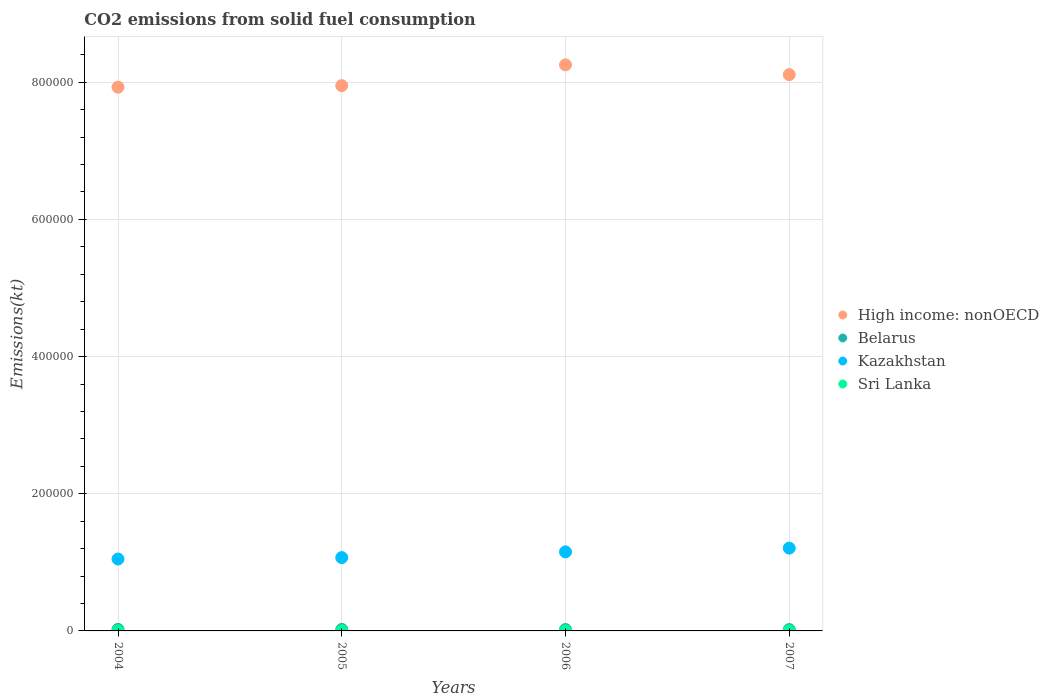Is the number of dotlines equal to the number of legend labels?
Provide a short and direct response. Yes. What is the amount of CO2 emitted in Belarus in 2004?
Provide a succinct answer. 2181.86. Across all years, what is the maximum amount of CO2 emitted in Sri Lanka?
Offer a very short reply. 231.02. Across all years, what is the minimum amount of CO2 emitted in Kazakhstan?
Ensure brevity in your answer.  1.05e+05. What is the total amount of CO2 emitted in Kazakhstan in the graph?
Provide a short and direct response. 4.48e+05. What is the difference between the amount of CO2 emitted in High income: nonOECD in 2004 and that in 2007?
Your answer should be compact. -1.83e+04. What is the difference between the amount of CO2 emitted in Sri Lanka in 2006 and the amount of CO2 emitted in High income: nonOECD in 2007?
Your answer should be compact. -8.11e+05. What is the average amount of CO2 emitted in Kazakhstan per year?
Give a very brief answer. 1.12e+05. In the year 2005, what is the difference between the amount of CO2 emitted in Kazakhstan and amount of CO2 emitted in High income: nonOECD?
Offer a terse response. -6.88e+05. What is the ratio of the amount of CO2 emitted in Kazakhstan in 2005 to that in 2006?
Provide a short and direct response. 0.93. Is the difference between the amount of CO2 emitted in Kazakhstan in 2004 and 2006 greater than the difference between the amount of CO2 emitted in High income: nonOECD in 2004 and 2006?
Keep it short and to the point. Yes. What is the difference between the highest and the second highest amount of CO2 emitted in Kazakhstan?
Keep it short and to the point. 5482.16. What is the difference between the highest and the lowest amount of CO2 emitted in Kazakhstan?
Keep it short and to the point. 1.59e+04. In how many years, is the amount of CO2 emitted in Kazakhstan greater than the average amount of CO2 emitted in Kazakhstan taken over all years?
Give a very brief answer. 2. Is the sum of the amount of CO2 emitted in Kazakhstan in 2006 and 2007 greater than the maximum amount of CO2 emitted in High income: nonOECD across all years?
Provide a short and direct response. No. Is it the case that in every year, the sum of the amount of CO2 emitted in Sri Lanka and amount of CO2 emitted in Belarus  is greater than the sum of amount of CO2 emitted in High income: nonOECD and amount of CO2 emitted in Kazakhstan?
Give a very brief answer. No. Does the amount of CO2 emitted in Kazakhstan monotonically increase over the years?
Provide a short and direct response. Yes. Is the amount of CO2 emitted in Kazakhstan strictly greater than the amount of CO2 emitted in Belarus over the years?
Provide a succinct answer. Yes. How many dotlines are there?
Provide a short and direct response. 4. How many years are there in the graph?
Your response must be concise. 4. What is the difference between two consecutive major ticks on the Y-axis?
Make the answer very short. 2.00e+05. Where does the legend appear in the graph?
Your answer should be compact. Center right. How are the legend labels stacked?
Provide a succinct answer. Vertical. What is the title of the graph?
Provide a short and direct response. CO2 emissions from solid fuel consumption. What is the label or title of the X-axis?
Your answer should be very brief. Years. What is the label or title of the Y-axis?
Ensure brevity in your answer.  Emissions(kt). What is the Emissions(kt) in High income: nonOECD in 2004?
Your answer should be very brief. 7.93e+05. What is the Emissions(kt) in Belarus in 2004?
Give a very brief answer. 2181.86. What is the Emissions(kt) in Kazakhstan in 2004?
Ensure brevity in your answer.  1.05e+05. What is the Emissions(kt) in Sri Lanka in 2004?
Ensure brevity in your answer.  231.02. What is the Emissions(kt) of High income: nonOECD in 2005?
Provide a short and direct response. 7.95e+05. What is the Emissions(kt) in Belarus in 2005?
Provide a short and direct response. 2167.2. What is the Emissions(kt) of Kazakhstan in 2005?
Offer a terse response. 1.07e+05. What is the Emissions(kt) of Sri Lanka in 2005?
Your answer should be very brief. 231.02. What is the Emissions(kt) of High income: nonOECD in 2006?
Your answer should be very brief. 8.25e+05. What is the Emissions(kt) in Belarus in 2006?
Keep it short and to the point. 2057.19. What is the Emissions(kt) in Kazakhstan in 2006?
Offer a terse response. 1.15e+05. What is the Emissions(kt) in Sri Lanka in 2006?
Give a very brief answer. 227.35. What is the Emissions(kt) of High income: nonOECD in 2007?
Provide a short and direct response. 8.11e+05. What is the Emissions(kt) in Belarus in 2007?
Offer a very short reply. 1961.85. What is the Emissions(kt) of Kazakhstan in 2007?
Provide a succinct answer. 1.21e+05. What is the Emissions(kt) in Sri Lanka in 2007?
Your answer should be compact. 161.35. Across all years, what is the maximum Emissions(kt) of High income: nonOECD?
Offer a terse response. 8.25e+05. Across all years, what is the maximum Emissions(kt) in Belarus?
Give a very brief answer. 2181.86. Across all years, what is the maximum Emissions(kt) of Kazakhstan?
Your answer should be very brief. 1.21e+05. Across all years, what is the maximum Emissions(kt) in Sri Lanka?
Ensure brevity in your answer.  231.02. Across all years, what is the minimum Emissions(kt) of High income: nonOECD?
Your response must be concise. 7.93e+05. Across all years, what is the minimum Emissions(kt) of Belarus?
Make the answer very short. 1961.85. Across all years, what is the minimum Emissions(kt) in Kazakhstan?
Give a very brief answer. 1.05e+05. Across all years, what is the minimum Emissions(kt) of Sri Lanka?
Ensure brevity in your answer.  161.35. What is the total Emissions(kt) of High income: nonOECD in the graph?
Give a very brief answer. 3.22e+06. What is the total Emissions(kt) of Belarus in the graph?
Ensure brevity in your answer.  8368.09. What is the total Emissions(kt) of Kazakhstan in the graph?
Give a very brief answer. 4.48e+05. What is the total Emissions(kt) in Sri Lanka in the graph?
Your response must be concise. 850.74. What is the difference between the Emissions(kt) of High income: nonOECD in 2004 and that in 2005?
Make the answer very short. -2310.09. What is the difference between the Emissions(kt) in Belarus in 2004 and that in 2005?
Give a very brief answer. 14.67. What is the difference between the Emissions(kt) of Kazakhstan in 2004 and that in 2005?
Provide a short and direct response. -2108.53. What is the difference between the Emissions(kt) of High income: nonOECD in 2004 and that in 2006?
Offer a very short reply. -3.26e+04. What is the difference between the Emissions(kt) in Belarus in 2004 and that in 2006?
Provide a short and direct response. 124.68. What is the difference between the Emissions(kt) of Kazakhstan in 2004 and that in 2006?
Offer a very short reply. -1.04e+04. What is the difference between the Emissions(kt) of Sri Lanka in 2004 and that in 2006?
Your response must be concise. 3.67. What is the difference between the Emissions(kt) of High income: nonOECD in 2004 and that in 2007?
Offer a terse response. -1.83e+04. What is the difference between the Emissions(kt) in Belarus in 2004 and that in 2007?
Make the answer very short. 220.02. What is the difference between the Emissions(kt) in Kazakhstan in 2004 and that in 2007?
Ensure brevity in your answer.  -1.59e+04. What is the difference between the Emissions(kt) of Sri Lanka in 2004 and that in 2007?
Your answer should be compact. 69.67. What is the difference between the Emissions(kt) in High income: nonOECD in 2005 and that in 2006?
Your answer should be very brief. -3.03e+04. What is the difference between the Emissions(kt) of Belarus in 2005 and that in 2006?
Provide a short and direct response. 110.01. What is the difference between the Emissions(kt) in Kazakhstan in 2005 and that in 2006?
Offer a very short reply. -8302.09. What is the difference between the Emissions(kt) in Sri Lanka in 2005 and that in 2006?
Provide a succinct answer. 3.67. What is the difference between the Emissions(kt) of High income: nonOECD in 2005 and that in 2007?
Offer a terse response. -1.60e+04. What is the difference between the Emissions(kt) in Belarus in 2005 and that in 2007?
Make the answer very short. 205.35. What is the difference between the Emissions(kt) in Kazakhstan in 2005 and that in 2007?
Provide a short and direct response. -1.38e+04. What is the difference between the Emissions(kt) of Sri Lanka in 2005 and that in 2007?
Provide a short and direct response. 69.67. What is the difference between the Emissions(kt) of High income: nonOECD in 2006 and that in 2007?
Offer a very short reply. 1.42e+04. What is the difference between the Emissions(kt) of Belarus in 2006 and that in 2007?
Your answer should be compact. 95.34. What is the difference between the Emissions(kt) in Kazakhstan in 2006 and that in 2007?
Ensure brevity in your answer.  -5482.16. What is the difference between the Emissions(kt) of Sri Lanka in 2006 and that in 2007?
Provide a succinct answer. 66.01. What is the difference between the Emissions(kt) in High income: nonOECD in 2004 and the Emissions(kt) in Belarus in 2005?
Ensure brevity in your answer.  7.91e+05. What is the difference between the Emissions(kt) of High income: nonOECD in 2004 and the Emissions(kt) of Kazakhstan in 2005?
Offer a terse response. 6.86e+05. What is the difference between the Emissions(kt) of High income: nonOECD in 2004 and the Emissions(kt) of Sri Lanka in 2005?
Make the answer very short. 7.92e+05. What is the difference between the Emissions(kt) of Belarus in 2004 and the Emissions(kt) of Kazakhstan in 2005?
Keep it short and to the point. -1.05e+05. What is the difference between the Emissions(kt) of Belarus in 2004 and the Emissions(kt) of Sri Lanka in 2005?
Your response must be concise. 1950.84. What is the difference between the Emissions(kt) of Kazakhstan in 2004 and the Emissions(kt) of Sri Lanka in 2005?
Give a very brief answer. 1.05e+05. What is the difference between the Emissions(kt) in High income: nonOECD in 2004 and the Emissions(kt) in Belarus in 2006?
Provide a succinct answer. 7.91e+05. What is the difference between the Emissions(kt) of High income: nonOECD in 2004 and the Emissions(kt) of Kazakhstan in 2006?
Your answer should be very brief. 6.77e+05. What is the difference between the Emissions(kt) in High income: nonOECD in 2004 and the Emissions(kt) in Sri Lanka in 2006?
Your answer should be compact. 7.92e+05. What is the difference between the Emissions(kt) in Belarus in 2004 and the Emissions(kt) in Kazakhstan in 2006?
Give a very brief answer. -1.13e+05. What is the difference between the Emissions(kt) of Belarus in 2004 and the Emissions(kt) of Sri Lanka in 2006?
Ensure brevity in your answer.  1954.51. What is the difference between the Emissions(kt) in Kazakhstan in 2004 and the Emissions(kt) in Sri Lanka in 2006?
Offer a terse response. 1.05e+05. What is the difference between the Emissions(kt) in High income: nonOECD in 2004 and the Emissions(kt) in Belarus in 2007?
Provide a succinct answer. 7.91e+05. What is the difference between the Emissions(kt) in High income: nonOECD in 2004 and the Emissions(kt) in Kazakhstan in 2007?
Your answer should be very brief. 6.72e+05. What is the difference between the Emissions(kt) of High income: nonOECD in 2004 and the Emissions(kt) of Sri Lanka in 2007?
Keep it short and to the point. 7.93e+05. What is the difference between the Emissions(kt) of Belarus in 2004 and the Emissions(kt) of Kazakhstan in 2007?
Offer a very short reply. -1.19e+05. What is the difference between the Emissions(kt) in Belarus in 2004 and the Emissions(kt) in Sri Lanka in 2007?
Offer a very short reply. 2020.52. What is the difference between the Emissions(kt) in Kazakhstan in 2004 and the Emissions(kt) in Sri Lanka in 2007?
Ensure brevity in your answer.  1.05e+05. What is the difference between the Emissions(kt) in High income: nonOECD in 2005 and the Emissions(kt) in Belarus in 2006?
Provide a succinct answer. 7.93e+05. What is the difference between the Emissions(kt) of High income: nonOECD in 2005 and the Emissions(kt) of Kazakhstan in 2006?
Your answer should be very brief. 6.80e+05. What is the difference between the Emissions(kt) of High income: nonOECD in 2005 and the Emissions(kt) of Sri Lanka in 2006?
Offer a terse response. 7.95e+05. What is the difference between the Emissions(kt) of Belarus in 2005 and the Emissions(kt) of Kazakhstan in 2006?
Ensure brevity in your answer.  -1.13e+05. What is the difference between the Emissions(kt) in Belarus in 2005 and the Emissions(kt) in Sri Lanka in 2006?
Your answer should be very brief. 1939.84. What is the difference between the Emissions(kt) of Kazakhstan in 2005 and the Emissions(kt) of Sri Lanka in 2006?
Keep it short and to the point. 1.07e+05. What is the difference between the Emissions(kt) of High income: nonOECD in 2005 and the Emissions(kt) of Belarus in 2007?
Keep it short and to the point. 7.93e+05. What is the difference between the Emissions(kt) in High income: nonOECD in 2005 and the Emissions(kt) in Kazakhstan in 2007?
Offer a terse response. 6.74e+05. What is the difference between the Emissions(kt) in High income: nonOECD in 2005 and the Emissions(kt) in Sri Lanka in 2007?
Your answer should be compact. 7.95e+05. What is the difference between the Emissions(kt) of Belarus in 2005 and the Emissions(kt) of Kazakhstan in 2007?
Provide a short and direct response. -1.19e+05. What is the difference between the Emissions(kt) of Belarus in 2005 and the Emissions(kt) of Sri Lanka in 2007?
Provide a short and direct response. 2005.85. What is the difference between the Emissions(kt) in Kazakhstan in 2005 and the Emissions(kt) in Sri Lanka in 2007?
Your answer should be very brief. 1.07e+05. What is the difference between the Emissions(kt) of High income: nonOECD in 2006 and the Emissions(kt) of Belarus in 2007?
Provide a short and direct response. 8.23e+05. What is the difference between the Emissions(kt) of High income: nonOECD in 2006 and the Emissions(kt) of Kazakhstan in 2007?
Ensure brevity in your answer.  7.05e+05. What is the difference between the Emissions(kt) in High income: nonOECD in 2006 and the Emissions(kt) in Sri Lanka in 2007?
Offer a very short reply. 8.25e+05. What is the difference between the Emissions(kt) in Belarus in 2006 and the Emissions(kt) in Kazakhstan in 2007?
Ensure brevity in your answer.  -1.19e+05. What is the difference between the Emissions(kt) of Belarus in 2006 and the Emissions(kt) of Sri Lanka in 2007?
Ensure brevity in your answer.  1895.84. What is the difference between the Emissions(kt) in Kazakhstan in 2006 and the Emissions(kt) in Sri Lanka in 2007?
Offer a terse response. 1.15e+05. What is the average Emissions(kt) of High income: nonOECD per year?
Your response must be concise. 8.06e+05. What is the average Emissions(kt) in Belarus per year?
Ensure brevity in your answer.  2092.02. What is the average Emissions(kt) of Kazakhstan per year?
Your response must be concise. 1.12e+05. What is the average Emissions(kt) in Sri Lanka per year?
Your response must be concise. 212.69. In the year 2004, what is the difference between the Emissions(kt) of High income: nonOECD and Emissions(kt) of Belarus?
Offer a very short reply. 7.91e+05. In the year 2004, what is the difference between the Emissions(kt) of High income: nonOECD and Emissions(kt) of Kazakhstan?
Give a very brief answer. 6.88e+05. In the year 2004, what is the difference between the Emissions(kt) of High income: nonOECD and Emissions(kt) of Sri Lanka?
Your response must be concise. 7.92e+05. In the year 2004, what is the difference between the Emissions(kt) in Belarus and Emissions(kt) in Kazakhstan?
Your answer should be very brief. -1.03e+05. In the year 2004, what is the difference between the Emissions(kt) of Belarus and Emissions(kt) of Sri Lanka?
Offer a terse response. 1950.84. In the year 2004, what is the difference between the Emissions(kt) of Kazakhstan and Emissions(kt) of Sri Lanka?
Provide a succinct answer. 1.05e+05. In the year 2005, what is the difference between the Emissions(kt) in High income: nonOECD and Emissions(kt) in Belarus?
Ensure brevity in your answer.  7.93e+05. In the year 2005, what is the difference between the Emissions(kt) in High income: nonOECD and Emissions(kt) in Kazakhstan?
Offer a terse response. 6.88e+05. In the year 2005, what is the difference between the Emissions(kt) in High income: nonOECD and Emissions(kt) in Sri Lanka?
Offer a very short reply. 7.95e+05. In the year 2005, what is the difference between the Emissions(kt) of Belarus and Emissions(kt) of Kazakhstan?
Make the answer very short. -1.05e+05. In the year 2005, what is the difference between the Emissions(kt) in Belarus and Emissions(kt) in Sri Lanka?
Give a very brief answer. 1936.18. In the year 2005, what is the difference between the Emissions(kt) of Kazakhstan and Emissions(kt) of Sri Lanka?
Offer a very short reply. 1.07e+05. In the year 2006, what is the difference between the Emissions(kt) in High income: nonOECD and Emissions(kt) in Belarus?
Provide a succinct answer. 8.23e+05. In the year 2006, what is the difference between the Emissions(kt) in High income: nonOECD and Emissions(kt) in Kazakhstan?
Make the answer very short. 7.10e+05. In the year 2006, what is the difference between the Emissions(kt) in High income: nonOECD and Emissions(kt) in Sri Lanka?
Give a very brief answer. 8.25e+05. In the year 2006, what is the difference between the Emissions(kt) of Belarus and Emissions(kt) of Kazakhstan?
Make the answer very short. -1.13e+05. In the year 2006, what is the difference between the Emissions(kt) in Belarus and Emissions(kt) in Sri Lanka?
Ensure brevity in your answer.  1829.83. In the year 2006, what is the difference between the Emissions(kt) of Kazakhstan and Emissions(kt) of Sri Lanka?
Provide a short and direct response. 1.15e+05. In the year 2007, what is the difference between the Emissions(kt) in High income: nonOECD and Emissions(kt) in Belarus?
Your answer should be compact. 8.09e+05. In the year 2007, what is the difference between the Emissions(kt) of High income: nonOECD and Emissions(kt) of Kazakhstan?
Give a very brief answer. 6.90e+05. In the year 2007, what is the difference between the Emissions(kt) of High income: nonOECD and Emissions(kt) of Sri Lanka?
Offer a terse response. 8.11e+05. In the year 2007, what is the difference between the Emissions(kt) of Belarus and Emissions(kt) of Kazakhstan?
Provide a succinct answer. -1.19e+05. In the year 2007, what is the difference between the Emissions(kt) of Belarus and Emissions(kt) of Sri Lanka?
Make the answer very short. 1800.5. In the year 2007, what is the difference between the Emissions(kt) of Kazakhstan and Emissions(kt) of Sri Lanka?
Offer a terse response. 1.21e+05. What is the ratio of the Emissions(kt) in High income: nonOECD in 2004 to that in 2005?
Offer a very short reply. 1. What is the ratio of the Emissions(kt) in Belarus in 2004 to that in 2005?
Your answer should be compact. 1.01. What is the ratio of the Emissions(kt) of Kazakhstan in 2004 to that in 2005?
Provide a succinct answer. 0.98. What is the ratio of the Emissions(kt) in High income: nonOECD in 2004 to that in 2006?
Ensure brevity in your answer.  0.96. What is the ratio of the Emissions(kt) of Belarus in 2004 to that in 2006?
Keep it short and to the point. 1.06. What is the ratio of the Emissions(kt) of Kazakhstan in 2004 to that in 2006?
Provide a succinct answer. 0.91. What is the ratio of the Emissions(kt) in Sri Lanka in 2004 to that in 2006?
Offer a terse response. 1.02. What is the ratio of the Emissions(kt) in High income: nonOECD in 2004 to that in 2007?
Your response must be concise. 0.98. What is the ratio of the Emissions(kt) of Belarus in 2004 to that in 2007?
Keep it short and to the point. 1.11. What is the ratio of the Emissions(kt) of Kazakhstan in 2004 to that in 2007?
Your answer should be very brief. 0.87. What is the ratio of the Emissions(kt) in Sri Lanka in 2004 to that in 2007?
Your answer should be very brief. 1.43. What is the ratio of the Emissions(kt) in High income: nonOECD in 2005 to that in 2006?
Your answer should be very brief. 0.96. What is the ratio of the Emissions(kt) of Belarus in 2005 to that in 2006?
Provide a succinct answer. 1.05. What is the ratio of the Emissions(kt) of Kazakhstan in 2005 to that in 2006?
Offer a very short reply. 0.93. What is the ratio of the Emissions(kt) of Sri Lanka in 2005 to that in 2006?
Your response must be concise. 1.02. What is the ratio of the Emissions(kt) of High income: nonOECD in 2005 to that in 2007?
Offer a terse response. 0.98. What is the ratio of the Emissions(kt) in Belarus in 2005 to that in 2007?
Your response must be concise. 1.1. What is the ratio of the Emissions(kt) of Kazakhstan in 2005 to that in 2007?
Your answer should be very brief. 0.89. What is the ratio of the Emissions(kt) in Sri Lanka in 2005 to that in 2007?
Your answer should be compact. 1.43. What is the ratio of the Emissions(kt) of High income: nonOECD in 2006 to that in 2007?
Provide a short and direct response. 1.02. What is the ratio of the Emissions(kt) of Belarus in 2006 to that in 2007?
Offer a terse response. 1.05. What is the ratio of the Emissions(kt) of Kazakhstan in 2006 to that in 2007?
Offer a terse response. 0.95. What is the ratio of the Emissions(kt) in Sri Lanka in 2006 to that in 2007?
Your answer should be very brief. 1.41. What is the difference between the highest and the second highest Emissions(kt) of High income: nonOECD?
Offer a very short reply. 1.42e+04. What is the difference between the highest and the second highest Emissions(kt) in Belarus?
Your answer should be very brief. 14.67. What is the difference between the highest and the second highest Emissions(kt) of Kazakhstan?
Make the answer very short. 5482.16. What is the difference between the highest and the second highest Emissions(kt) in Sri Lanka?
Ensure brevity in your answer.  0. What is the difference between the highest and the lowest Emissions(kt) of High income: nonOECD?
Your answer should be compact. 3.26e+04. What is the difference between the highest and the lowest Emissions(kt) in Belarus?
Provide a short and direct response. 220.02. What is the difference between the highest and the lowest Emissions(kt) of Kazakhstan?
Provide a short and direct response. 1.59e+04. What is the difference between the highest and the lowest Emissions(kt) of Sri Lanka?
Ensure brevity in your answer.  69.67. 